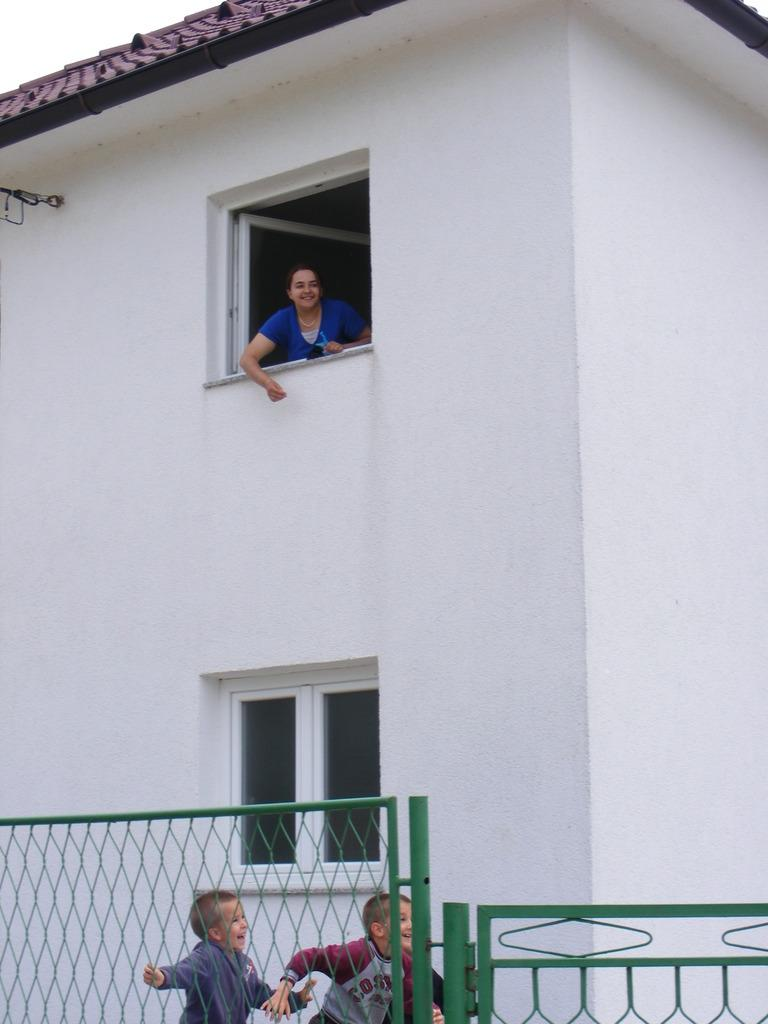What is the color of the building in the image? The building in the image is white-colored. What feature does the building have? The building has windows. What is the color of the gate in the image? The gate in the image is green-colored. How many children are in the image? There are two children in the image. Who else is present in the image besides the children? There is a woman in the image. What is the emotional state of the people in the image? The people in the image (children and woman) have smiles on their faces, indicating a positive or happy emotional state. What date is circled on the calendar in the image? There is no calendar present in the image. What type of cake is being served to the people in the image? There is no cake present in the image. 